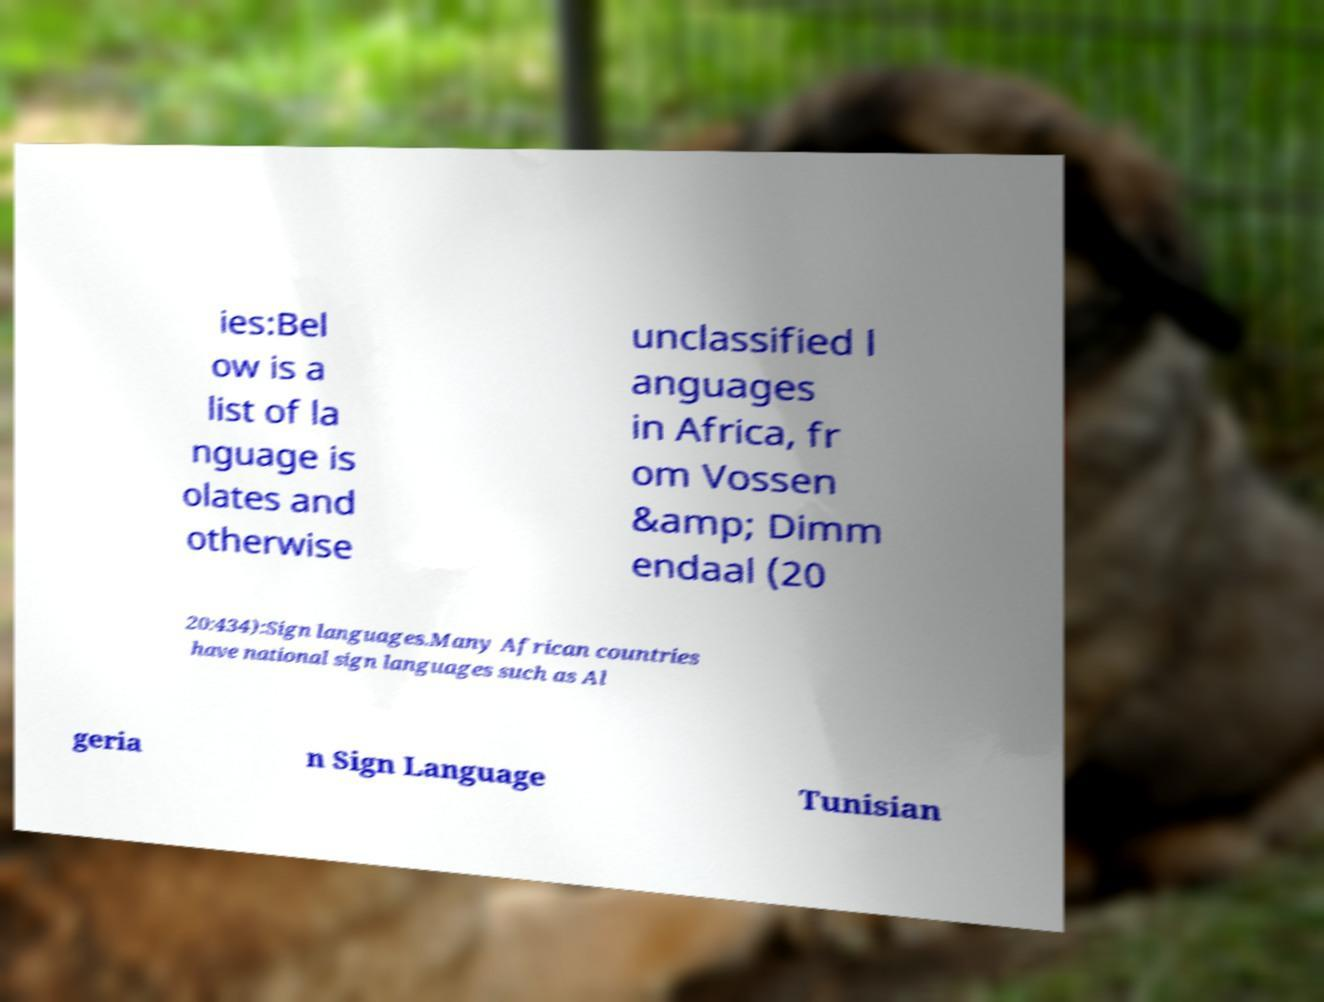Please read and relay the text visible in this image. What does it say? ies:Bel ow is a list of la nguage is olates and otherwise unclassified l anguages in Africa, fr om Vossen &amp; Dimm endaal (20 20:434):Sign languages.Many African countries have national sign languages such as Al geria n Sign Language Tunisian 